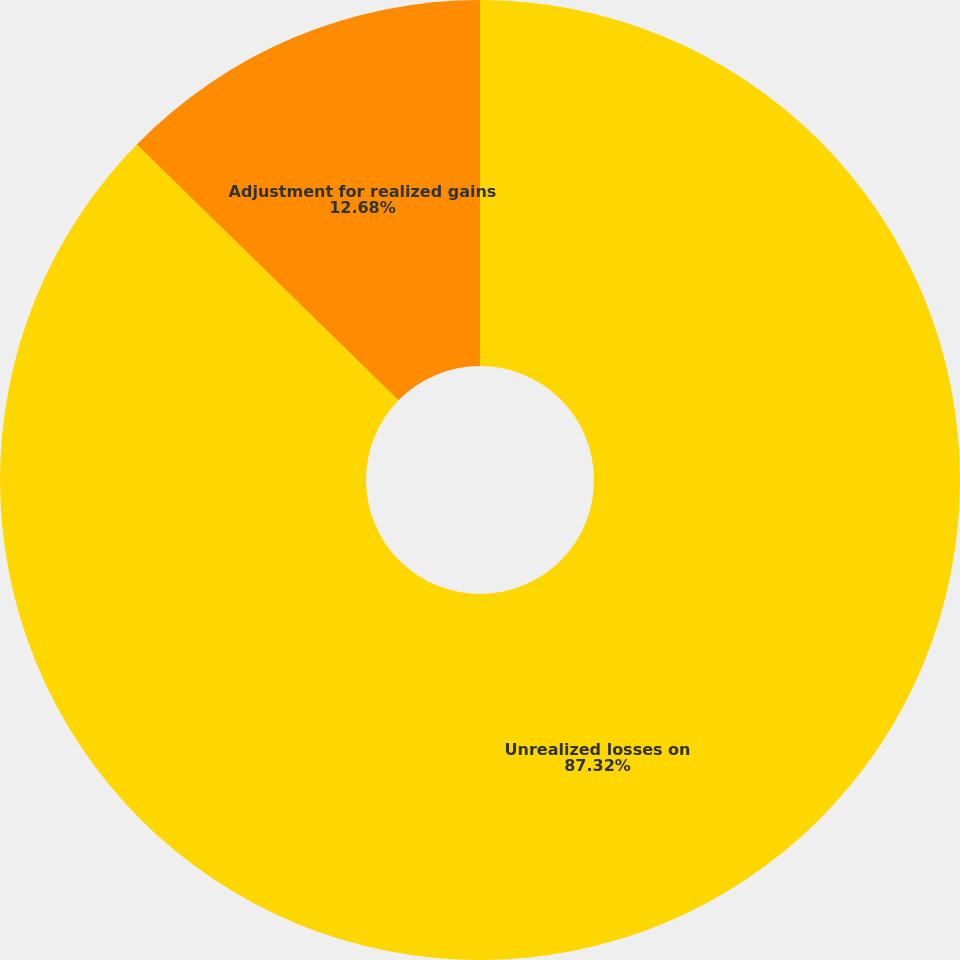<chart> <loc_0><loc_0><loc_500><loc_500><pie_chart><fcel>Unrealized losses on<fcel>Adjustment for realized gains<nl><fcel>87.32%<fcel>12.68%<nl></chart> 